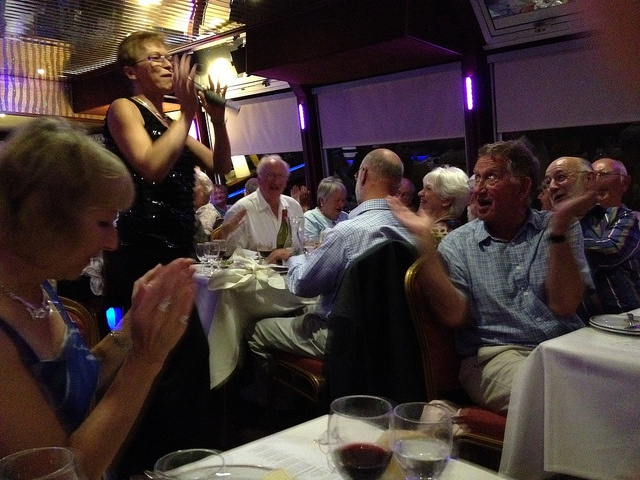Describe the objects in this image and their specific colors. I can see people in navy, black, maroon, and gray tones, people in navy, black, maroon, and gray tones, people in navy, black, gray, and maroon tones, tv in navy, black, and purple tones, and dining table in navy, gray, darkgray, and black tones in this image. 